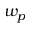Convert formula to latex. <formula><loc_0><loc_0><loc_500><loc_500>w _ { p }</formula> 